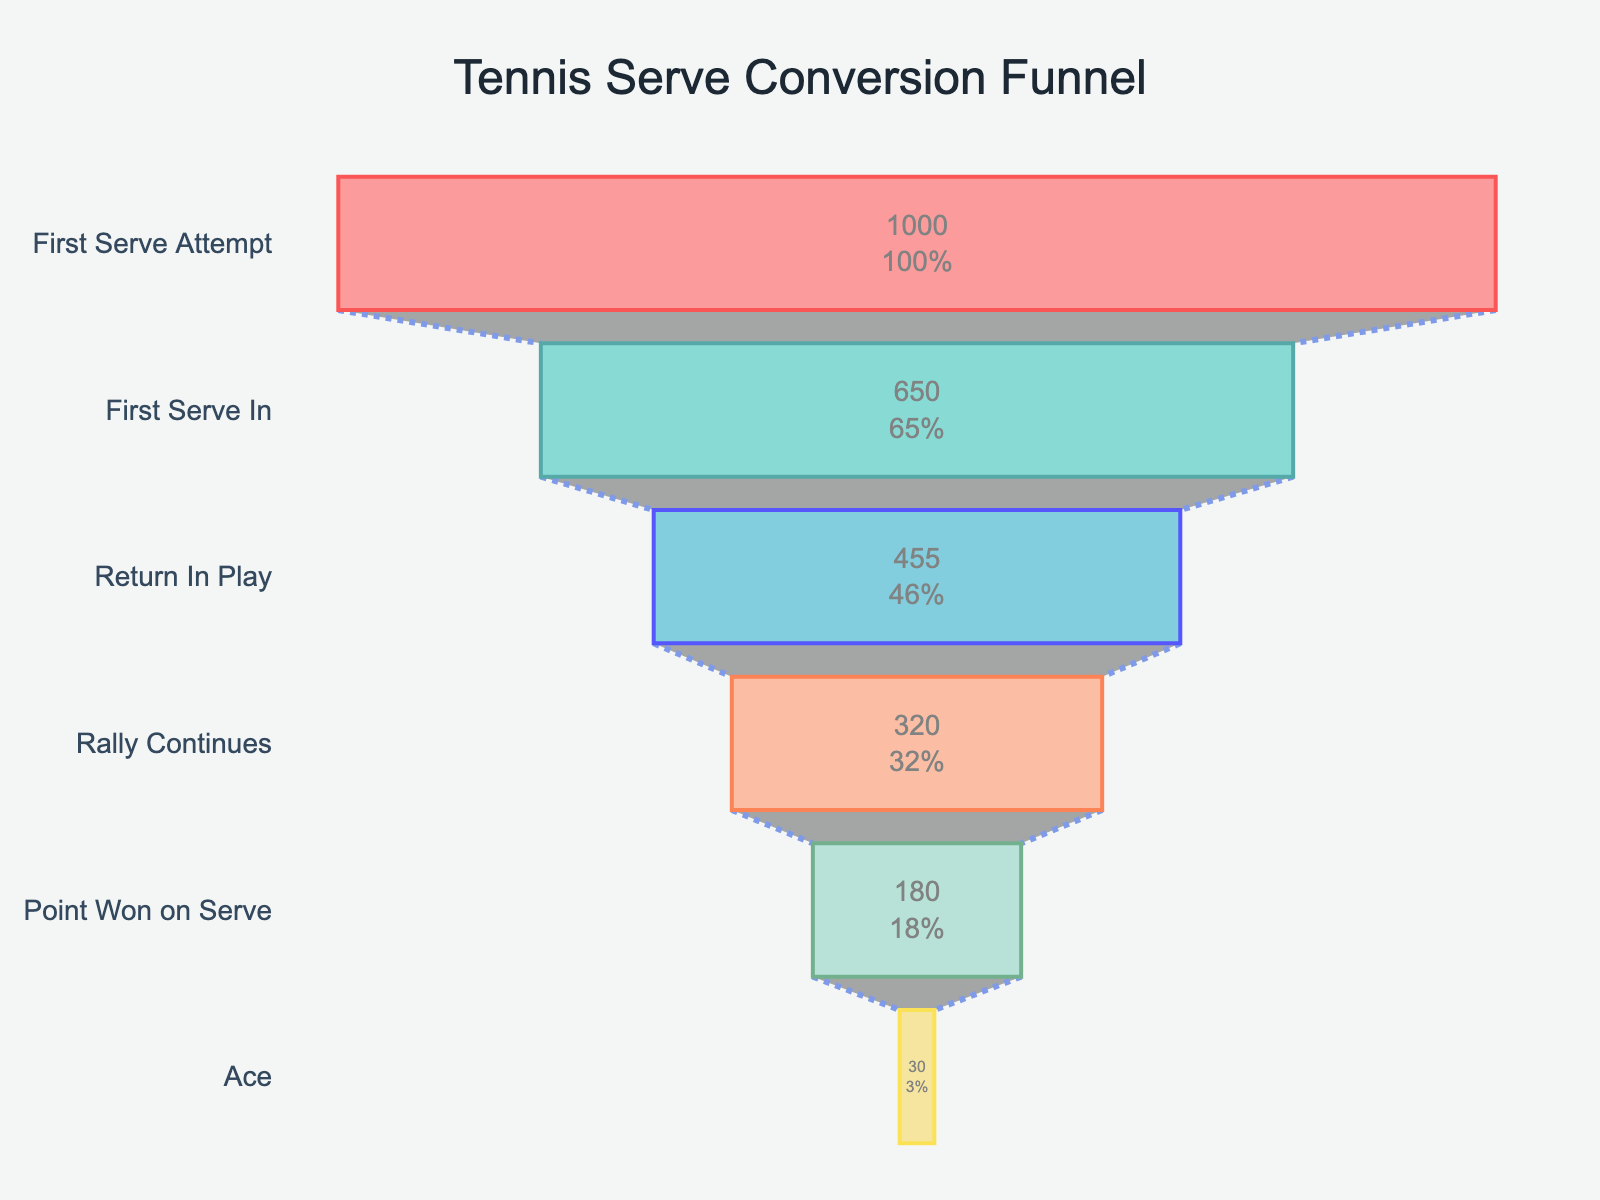How many players attempted the first serve originally? Refer to the "First Serve Attempt" stage at the top of the funnel. It indicates 1000 players initially attempted the first serve.
Answer: 1000 What is the percent of serves that resulted in a point won on the first serve? Look at the "Point Won on Serve" stage in the funnel chart, which shows that 180 out of 1000 serves resulted in a point won. The percentage listed is 18%.
Answer: 18% How many serves ended up as an ace? Refer to the "Ace" stage. It shows that 30 serves ended up as an ace.
Answer: 30 What is the difference in the number of players between the "First Serve In" and "Return In Play" stages? Subtract the number of players in the "Return In Play" stage from the "First Serve In" stage (650 - 455). This gives the difference.
Answer: 195 Which stage had the greatest drop in player count? Examine the player counts in each stage and find the largest decrease from one stage to the next. The largest drop is from "First Serve Attempt" to "First Serve In" (1000 - 650 = 350).
Answer: First Serve Attempt to First Serve In In what percentage of rallies did the point get won on the first serve after the rally continued? Look at the "Rally Continues" and "Point Won on Serve" stages. 180 out of 320 rallies resulted in a point won. Calculate the percentage: (180 / 320) * 100%.
Answer: 56.25% What is the ratio of aces to total points won on serve? The number of aces is 30, and the total points won on serve is 180. Calculate the ratio by dividing the number of aces by the total points won on serve (30 / 180).
Answer: 1:6 How many additional serves would need to result in an ace to achieve a 4% ace rate? First, calculate the current number of total serves (1000). To achieve a 4% ace rate, we need 4% of 1000 serves to be aces, which is 0.04 * 1000 = 40 aces. The difference between 40 aces and the current 30 aces equals the number of additional serves needed.
Answer: 10 What is the difference in percentage between serves that made it into play and serves that ended up in a rally? Look at the percentages for "First Serve In" and "Return In Play". Subtract the percentage of serves that ended up in a rally (32%) from those that made it into play (45.5%).
Answer: 13.5% Calculate the overall conversion rate from first serve attempt to point won. The "Point Won on Serve" stage shows that 180 of the original 1000 serves resulted in a point won. The overall conversion rate is calculated as (180 / 1000) * 100%.
Answer: 18% 